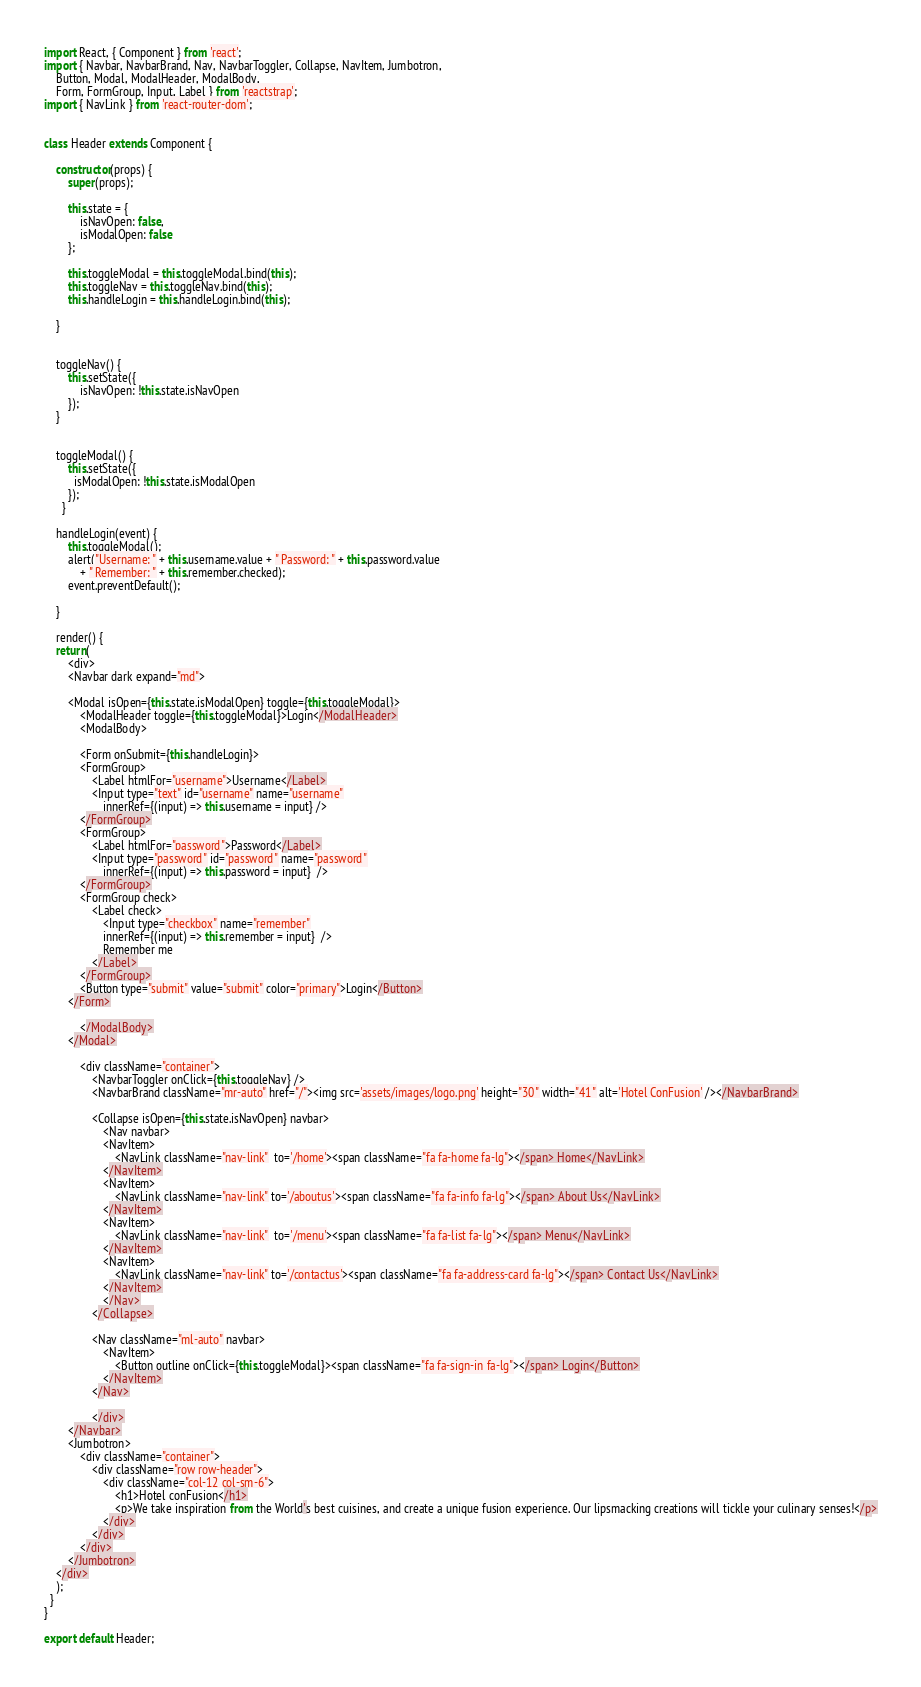<code> <loc_0><loc_0><loc_500><loc_500><_JavaScript_>import React, { Component } from 'react';
import { Navbar, NavbarBrand, Nav, NavbarToggler, Collapse, NavItem, Jumbotron,
    Button, Modal, ModalHeader, ModalBody,
    Form, FormGroup, Input, Label } from 'reactstrap';
import { NavLink } from 'react-router-dom';


class Header extends Component {

    constructor(props) {
        super(props);

        this.state = {
            isNavOpen: false,
            isModalOpen: false
        };

        this.toggleModal = this.toggleModal.bind(this);
        this.toggleNav = this.toggleNav.bind(this);
        this.handleLogin = this.handleLogin.bind(this);

    }

    
    toggleNav() {
        this.setState({
            isNavOpen: !this.state.isNavOpen
        });
    }

    
    toggleModal() {
        this.setState({
          isModalOpen: !this.state.isModalOpen
        });
      }

    handleLogin(event) {
        this.toggleModal();
        alert("Username: " + this.username.value + " Password: " + this.password.value
            + " Remember: " + this.remember.checked);
        event.preventDefault();

    }

    render() {
    return(
        <div>
        <Navbar dark expand="md">

        <Modal isOpen={this.state.isModalOpen} toggle={this.toggleModal}>
            <ModalHeader toggle={this.toggleModal}>Login</ModalHeader>
            <ModalBody>

            <Form onSubmit={this.handleLogin}>
            <FormGroup>
                <Label htmlFor="username">Username</Label>
                <Input type="text" id="username" name="username"
                    innerRef={(input) => this.username = input} />
            </FormGroup>
            <FormGroup>
                <Label htmlFor="password">Password</Label>
                <Input type="password" id="password" name="password"
                    innerRef={(input) => this.password = input}  />
            </FormGroup>
            <FormGroup check>
                <Label check>
                    <Input type="checkbox" name="remember"
                    innerRef={(input) => this.remember = input}  />
                    Remember me
                </Label>
            </FormGroup>
            <Button type="submit" value="submit" color="primary">Login</Button>
        </Form>

            </ModalBody>
        </Modal>

            <div className="container">
                <NavbarToggler onClick={this.toggleNav} />
                <NavbarBrand className="mr-auto" href="/"><img src='assets/images/logo.png' height="30" width="41" alt='Hotel ConFusion' /></NavbarBrand>

                <Collapse isOpen={this.state.isNavOpen} navbar>
                    <Nav navbar>
                    <NavItem>
                        <NavLink className="nav-link"  to='/home'><span className="fa fa-home fa-lg"></span> Home</NavLink>
                    </NavItem>
                    <NavItem>
                        <NavLink className="nav-link" to='/aboutus'><span className="fa fa-info fa-lg"></span> About Us</NavLink>
                    </NavItem>
                    <NavItem>
                        <NavLink className="nav-link"  to='/menu'><span className="fa fa-list fa-lg"></span> Menu</NavLink>
                    </NavItem>
                    <NavItem>
                        <NavLink className="nav-link" to='/contactus'><span className="fa fa-address-card fa-lg"></span> Contact Us</NavLink>
                    </NavItem>
                    </Nav>
                </Collapse>

                <Nav className="ml-auto" navbar>
                    <NavItem>
                        <Button outline onClick={this.toggleModal}><span className="fa fa-sign-in fa-lg"></span> Login</Button>
                    </NavItem>
                </Nav>

                </div>
        </Navbar>
        <Jumbotron>
            <div className="container">
                <div className="row row-header">
                    <div className="col-12 col-sm-6">
                        <h1>Hotel conFusion</h1>
                        <p>We take inspiration from the World's best cuisines, and create a unique fusion experience. Our lipsmacking creations will tickle your culinary senses!</p>
                    </div>
                </div>
            </div>
        </Jumbotron>
    </div>
    );
  }
}

export default Header;</code> 